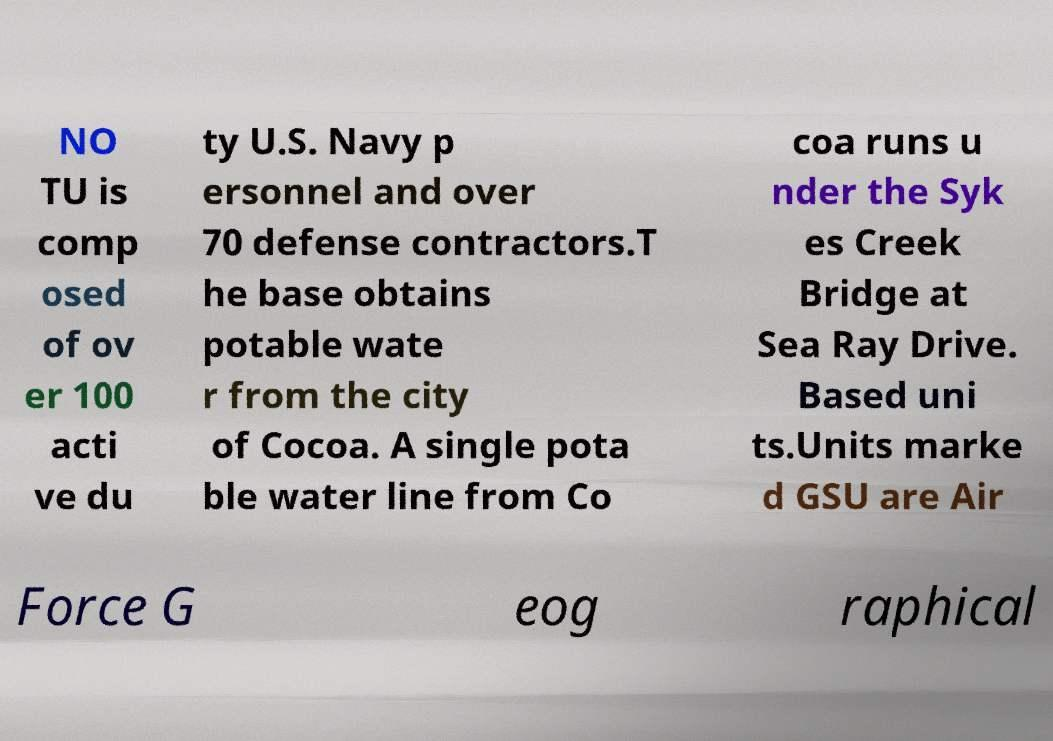Please identify and transcribe the text found in this image. NO TU is comp osed of ov er 100 acti ve du ty U.S. Navy p ersonnel and over 70 defense contractors.T he base obtains potable wate r from the city of Cocoa. A single pota ble water line from Co coa runs u nder the Syk es Creek Bridge at Sea Ray Drive. Based uni ts.Units marke d GSU are Air Force G eog raphical 